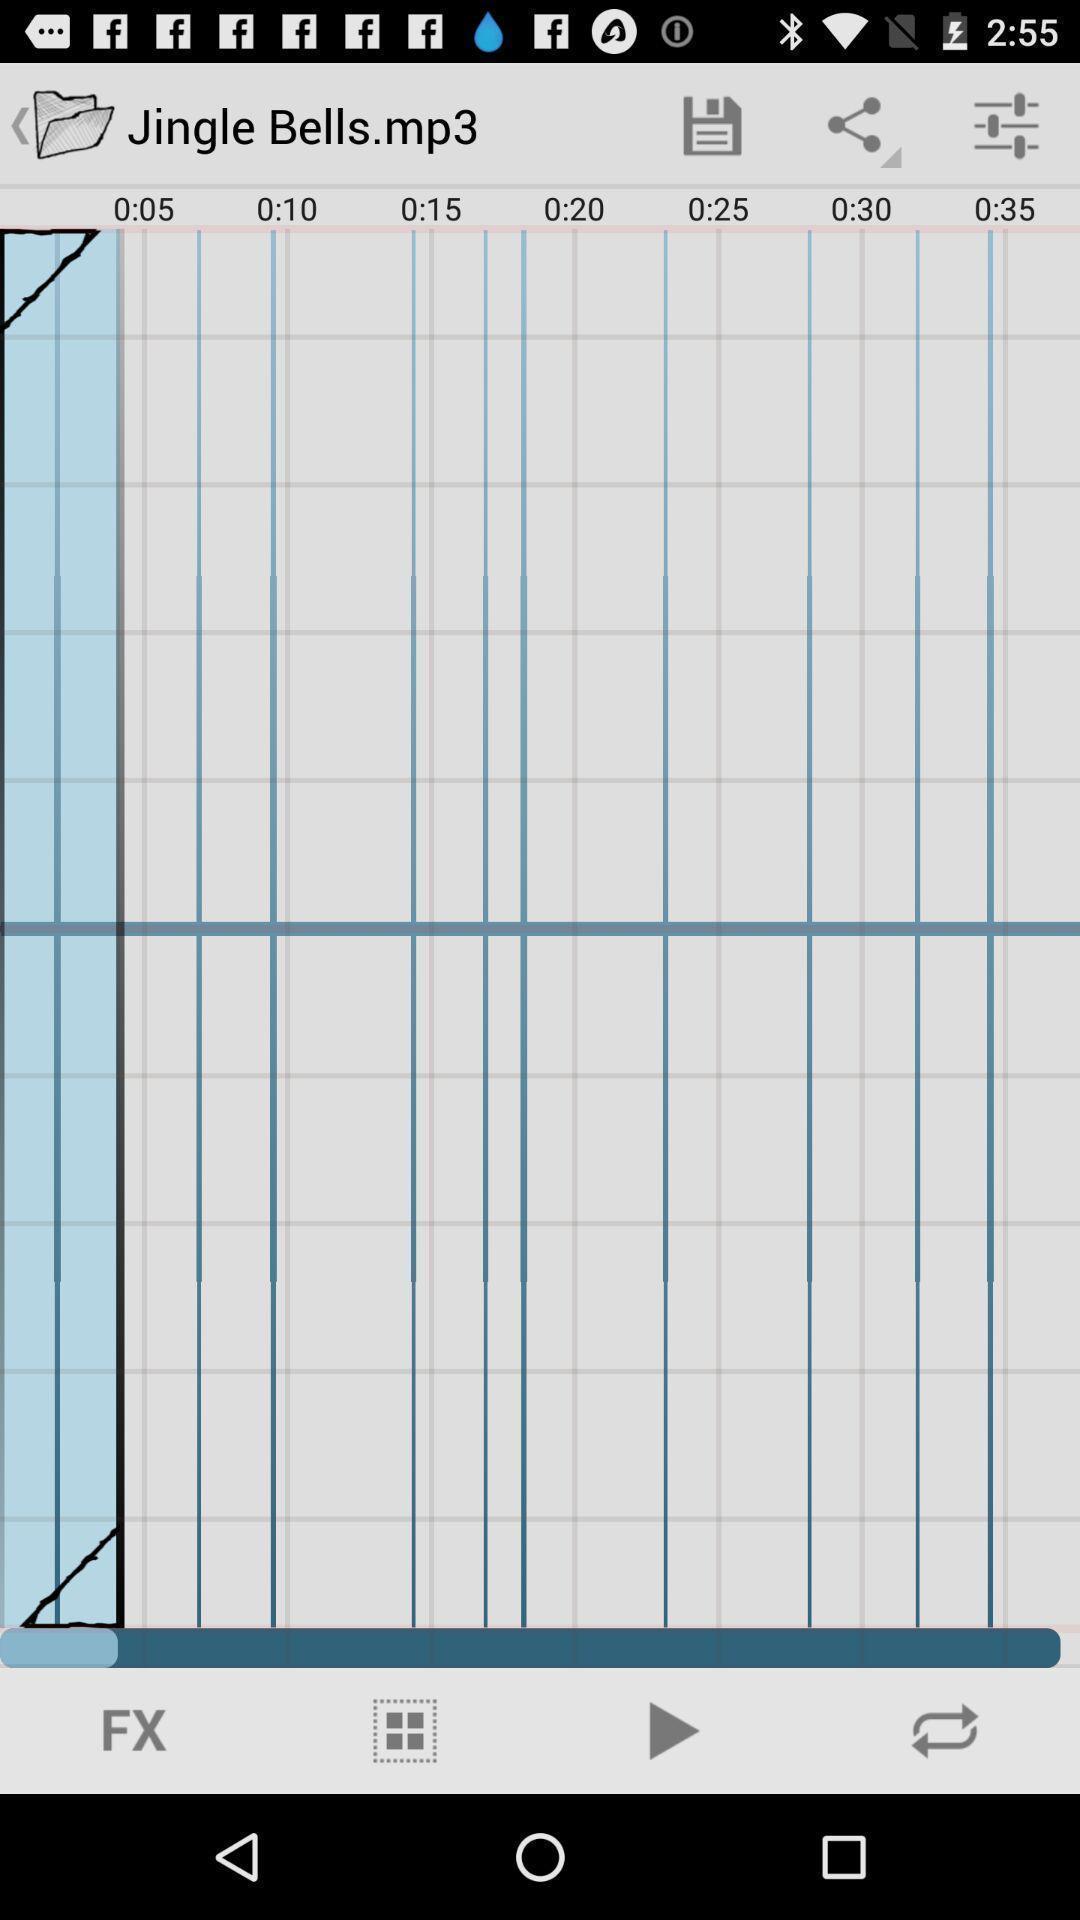Tell me about the visual elements in this screen capture. Ringtone playing in a ringtone creator app. 